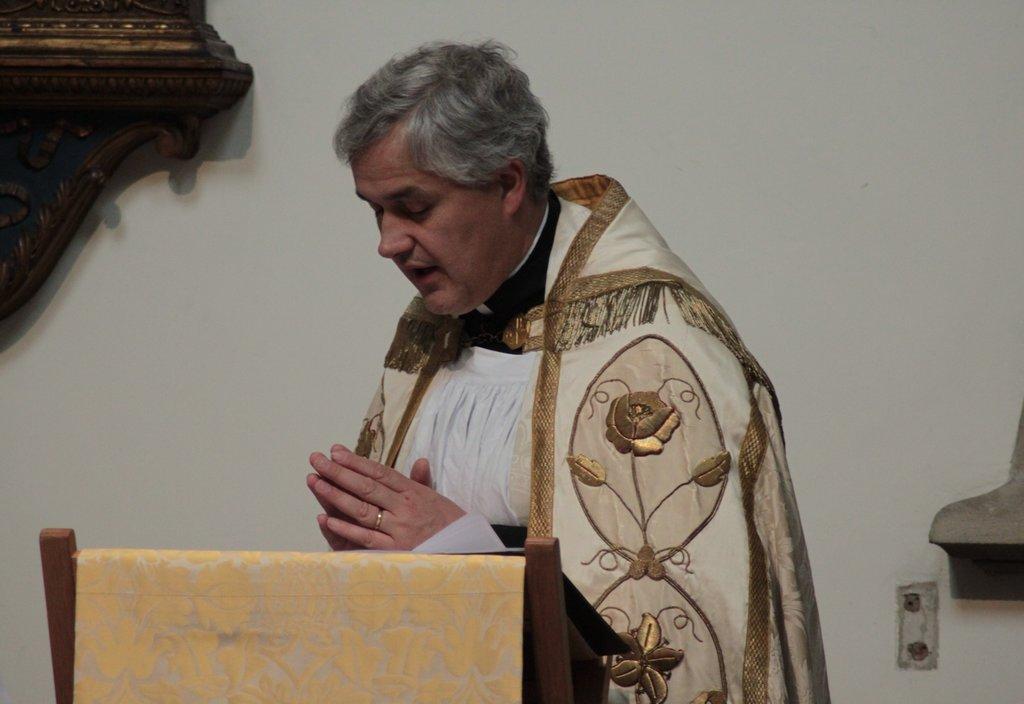Could you give a brief overview of what you see in this image? In the picture we can see a church father standing on the floor and praying and front of him we can see a part of chair and beside him we can see a wall with some wooden plank design on it. 